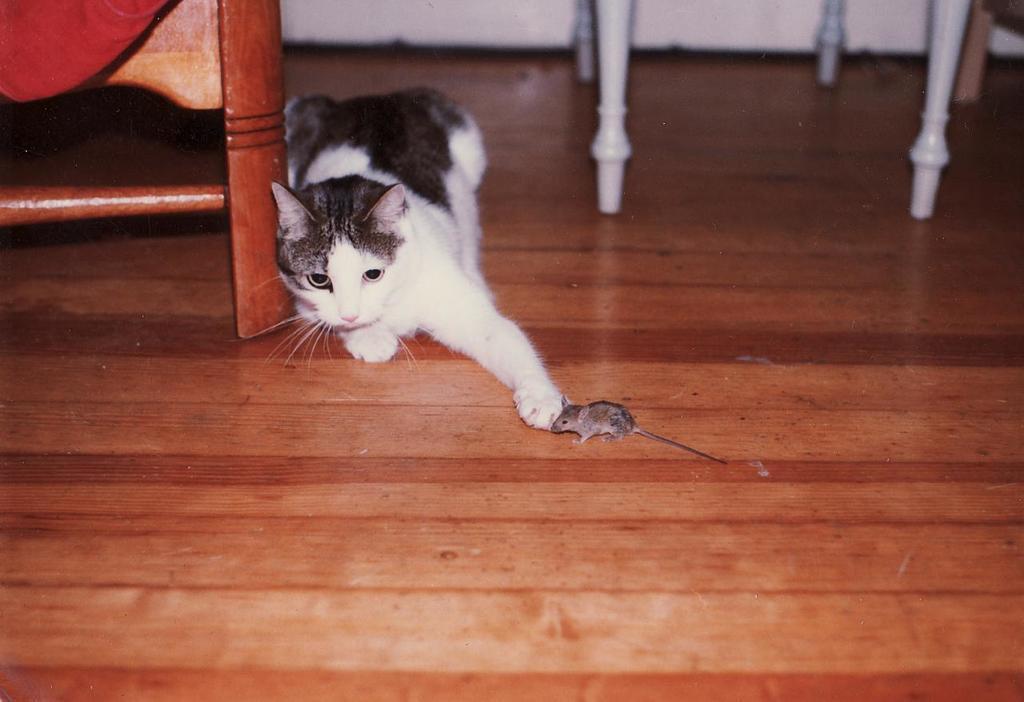Can you describe this image briefly? In this image, I can see a cat, mouse and the wooden objects on the floor. 